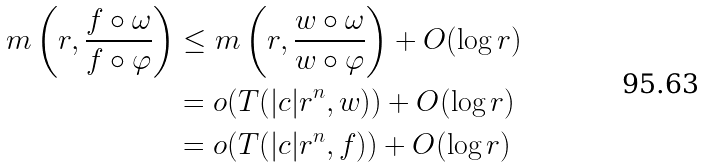<formula> <loc_0><loc_0><loc_500><loc_500>m \left ( r , \frac { f \circ \omega } { f \circ \varphi } \right ) & \leq m \left ( r , \frac { w \circ \omega } { w \circ \varphi } \right ) + O ( \log r ) \\ & = o ( T ( | c | r ^ { n } , w ) ) + O ( \log r ) \\ & = o ( T ( | c | r ^ { n } , f ) ) + O ( \log r )</formula> 